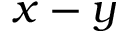Convert formula to latex. <formula><loc_0><loc_0><loc_500><loc_500>x - y</formula> 